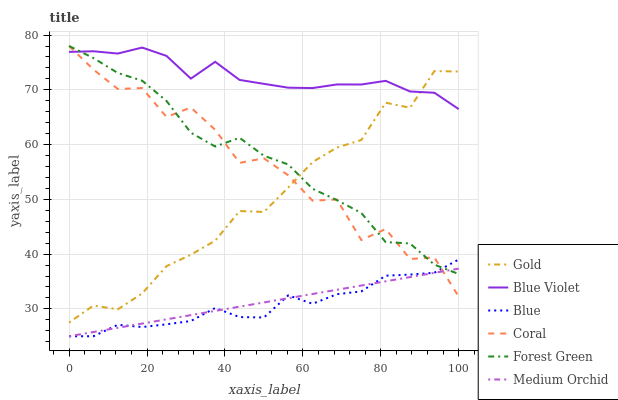Does Blue have the minimum area under the curve?
Answer yes or no. Yes. Does Blue Violet have the maximum area under the curve?
Answer yes or no. Yes. Does Gold have the minimum area under the curve?
Answer yes or no. No. Does Gold have the maximum area under the curve?
Answer yes or no. No. Is Medium Orchid the smoothest?
Answer yes or no. Yes. Is Coral the roughest?
Answer yes or no. Yes. Is Gold the smoothest?
Answer yes or no. No. Is Gold the roughest?
Answer yes or no. No. Does Gold have the lowest value?
Answer yes or no. No. Does Forest Green have the highest value?
Answer yes or no. Yes. Does Gold have the highest value?
Answer yes or no. No. Is Medium Orchid less than Blue Violet?
Answer yes or no. Yes. Is Blue Violet greater than Blue?
Answer yes or no. Yes. Does Gold intersect Forest Green?
Answer yes or no. Yes. Is Gold less than Forest Green?
Answer yes or no. No. Is Gold greater than Forest Green?
Answer yes or no. No. Does Medium Orchid intersect Blue Violet?
Answer yes or no. No. 